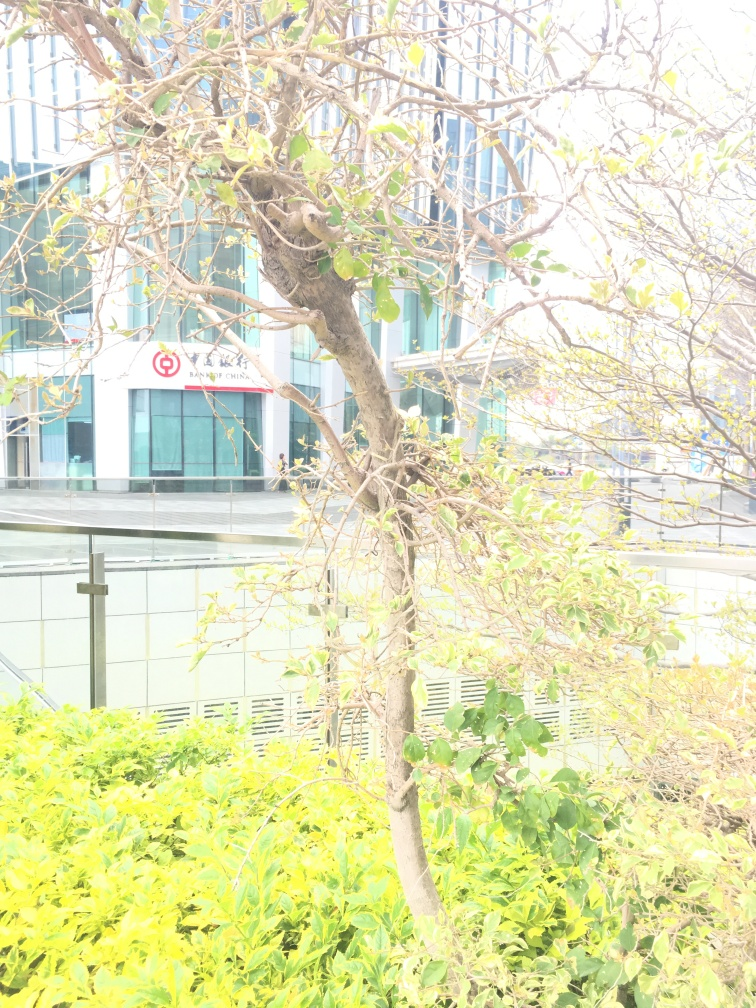Can you describe the overall lighting and exposure of this image? The image appears to be overexposed, resulting in a loss of detail and a washed-out look in several areas, particularly on the leaves and branches of the green plants. This high exposure obscures finer details, reducing the visual contrast and making the scene look uniformly bright. 